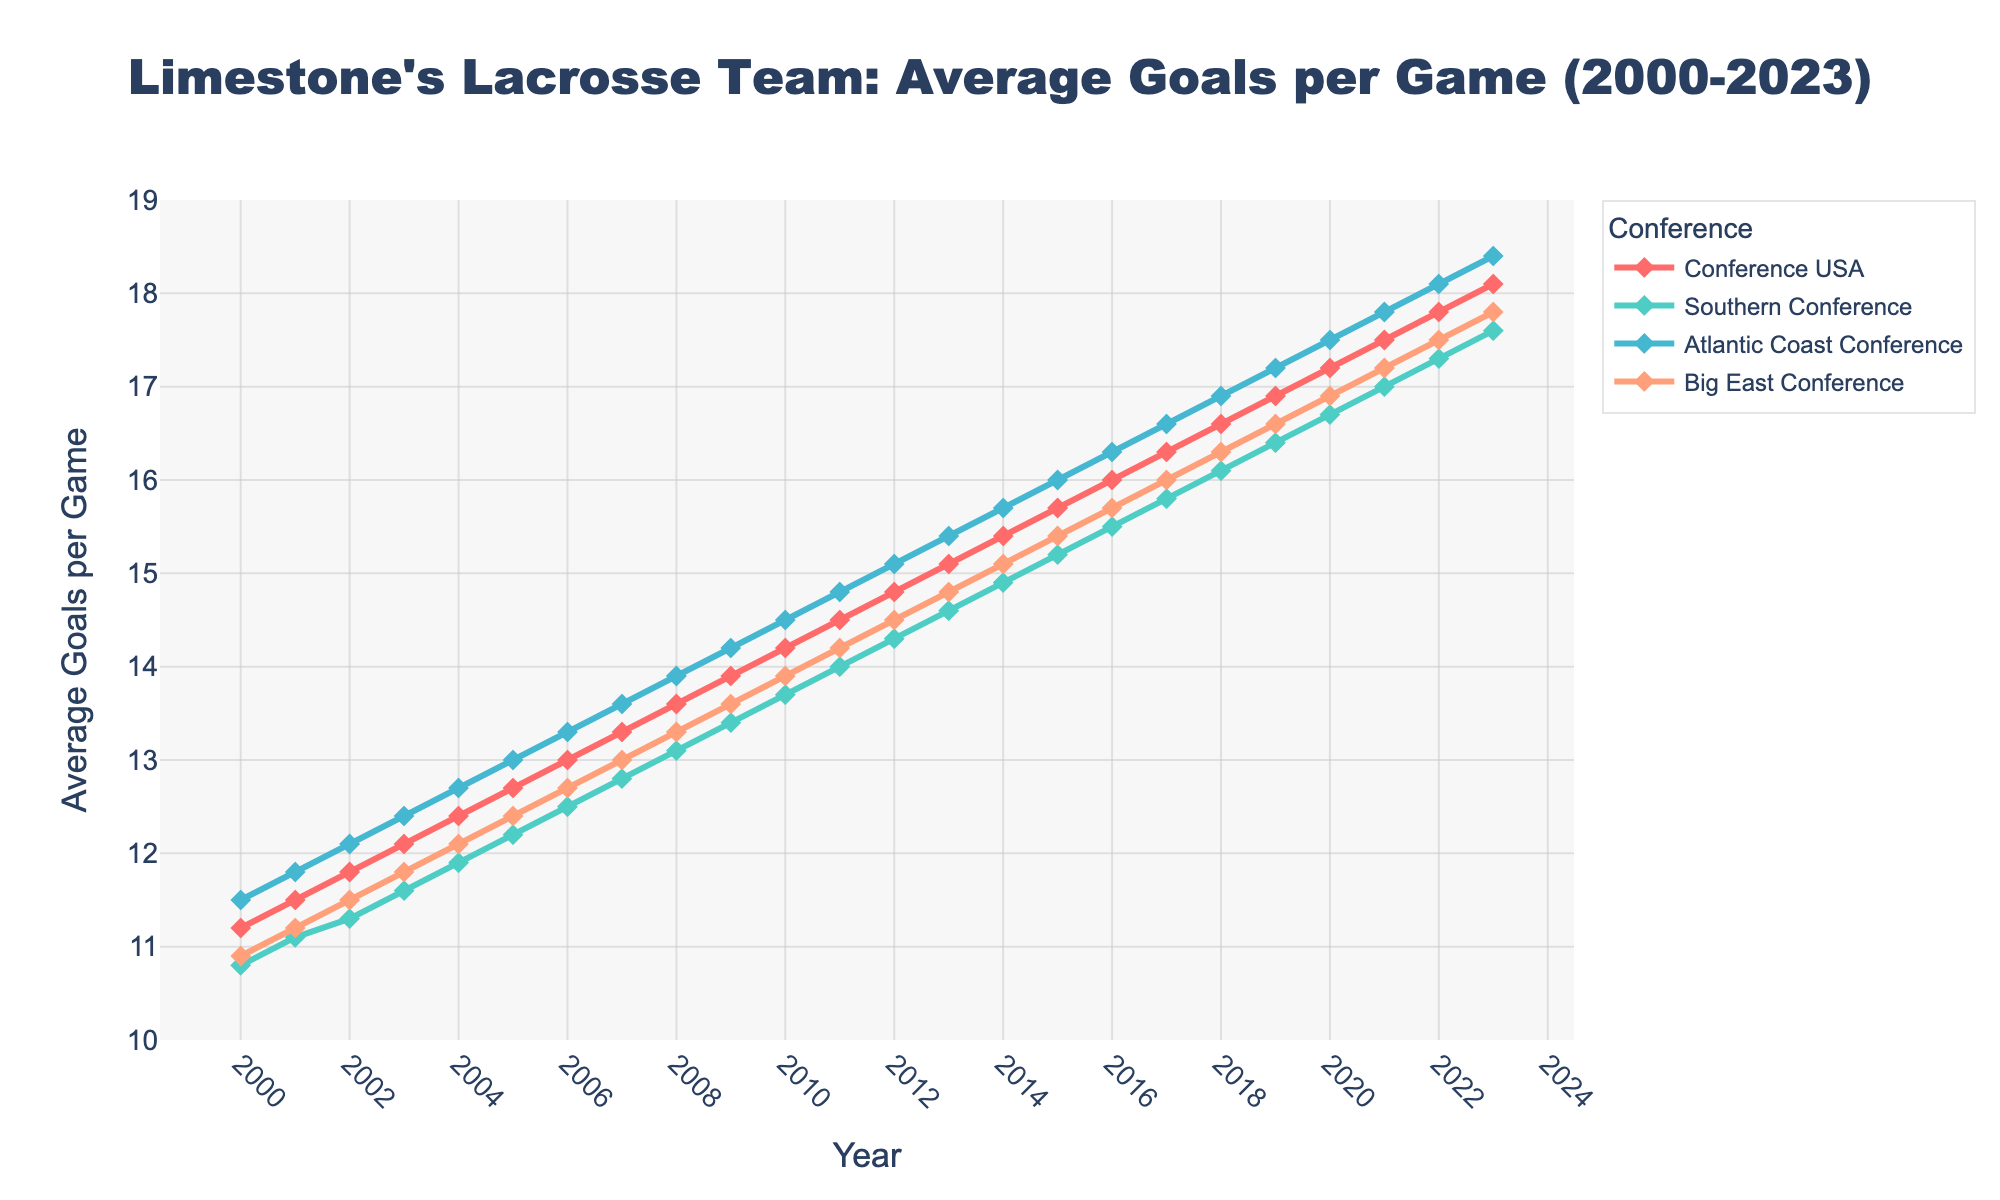What is the trend in average goals scored per game by Limestone's lacrosse team from 2000 to 2023 in the Conference USA? The trend can be observed by looking at the line corresponding to the Conference USA from 2000 to 2023. This line shows a steady increase in the average goals scored per game, starting at 11.2 in 2000 and reaching 18.1 in 2023.
Answer: Steady increase Between which years did Southern Conference have its most significant increase in average goals scored per game? To determine the most significant increase, we look for the steepest slope in the line corresponding to the Southern Conference. The line shows the sharpest rise between 2013 (14.6) and 2017 (15.8), indicating a 1.2 goal increase.
Answer: 2013 to 2017 Which conference had the highest average goals per game in 2023? We look at the values at the endpoint of each line in 2023. The Atlantic Coast Conference had the highest value at 18.4.
Answer: Atlantic Coast Conference How many years did the Big East Conference surpass 15 average goals per game? Checking the line corresponding to the Big East Conference, it surpassed 15 average goals per game from 2016 to 2023. Counting these years gives us 8 years.
Answer: 8 years By how much did the average goals per game increase in the Southern Conference from 2000 to 2023? The starting value in 2000 is 10.8, and the ending value in 2023 is 17.6. The increase is calculated as 17.6 - 10.8 = 6.8.
Answer: 6.8 goals Which conference had the most consistent increase in average goals per game over the years? Consistency can be determined by looking for the smoothest, most linear increase without fluctuations. The line for the Big East Conference shows a steady increase from 2000 to 2023 without sharp peaks or dips, making it the most consistent.
Answer: Big East Conference In which year did Limestone's lacrosse team in the Atlantic Coast Conference surpass 15 average goals per game? We observe the line corresponding to the Atlantic Coast Conference and find it first surpasses 15 average goals per game in 2011.
Answer: 2011 What is the average value of goals per game in the Southern Conference from 2000 to 2010? Extracting the average values from 2000 to 2010 for the Southern Conference and summing them gives: (10.8 + 11.1 + 11.3 + 11.6 + 11.9 + 12.2 + 12.5 + 12.8 + 13.1 + 13.4 + 13.7) = 134.4. Dividing by 11 years gives 134.4 / 11 ≈ 12.22.
Answer: ≈ 12.22 Which conference had a higher average goal per game in 2005: Conference USA or Atlantic Coast Conference? Comparing the values for 2005, Conference USA had 12.7 and Atlantic Coast Conference had 13.0. Therefore, the Atlantic Coast Conference had a higher average goal per game in 2005.
Answer: Atlantic Coast Conference 